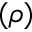<formula> <loc_0><loc_0><loc_500><loc_500>( \rho )</formula> 